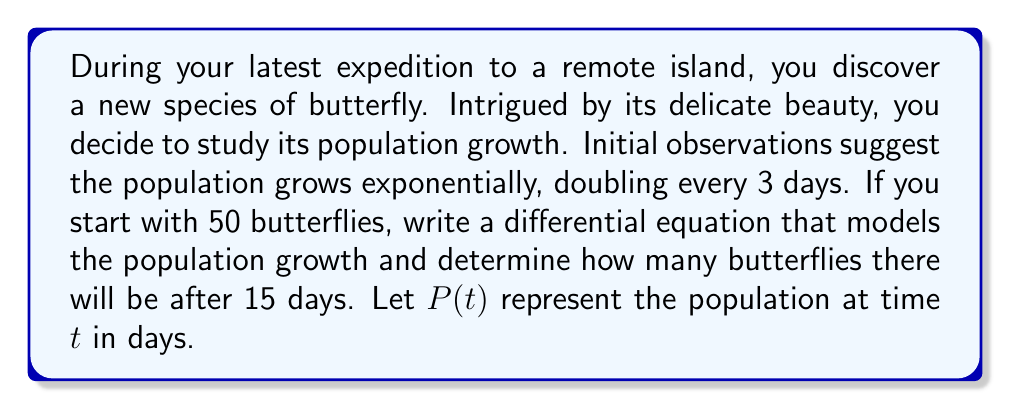Teach me how to tackle this problem. Let's approach this problem step by step:

1) First, we need to set up the differential equation. For exponential growth, the rate of change of the population is proportional to the current population:

   $$\frac{dP}{dt} = kP$$

   where $k$ is the growth rate constant.

2) We're told the population doubles every 3 days. Let's use this to find $k$:

   $$P(3) = 2P(0)$$
   $$P(0)e^{3k} = 2P(0)$$
   $$e^{3k} = 2$$
   $$3k = \ln(2)$$
   $$k = \frac{\ln(2)}{3}$$

3) Now our differential equation is:

   $$\frac{dP}{dt} = \frac{\ln(2)}{3}P$$

4) To solve this, we can separate variables and integrate:

   $$\int \frac{dP}{P} = \int \frac{\ln(2)}{3} dt$$
   $$\ln(P) = \frac{\ln(2)}{3}t + C$$

5) We can find $C$ using the initial condition $P(0) = 50$:

   $$\ln(50) = C$$
   $$C = \ln(50)$$

6) So our solution is:

   $$\ln(P) = \frac{\ln(2)}{3}t + \ln(50)$$
   $$P(t) = 50e^{\frac{\ln(2)}{3}t}$$

7) To find the population after 15 days, we calculate $P(15)$:

   $$P(15) = 50e^{\frac{\ln(2)}{3}(15)}$$
   $$P(15) = 50e^{5\ln(2)}$$
   $$P(15) = 50(2^5)$$
   $$P(15) = 1600$$

Therefore, after 15 days, there will be 1600 butterflies.
Answer: The differential equation modeling the population growth is:

$$\frac{dP}{dt} = \frac{\ln(2)}{3}P$$

The population after 15 days will be 1600 butterflies. 